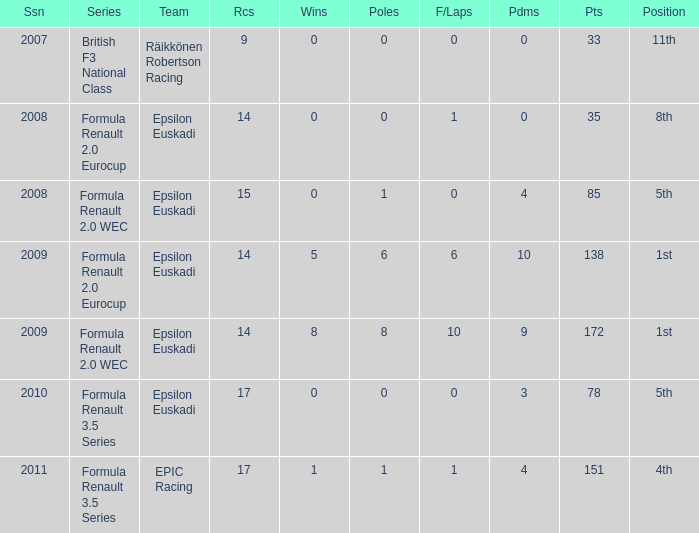How many podiums when he was in the british f3 national class series? 1.0. 